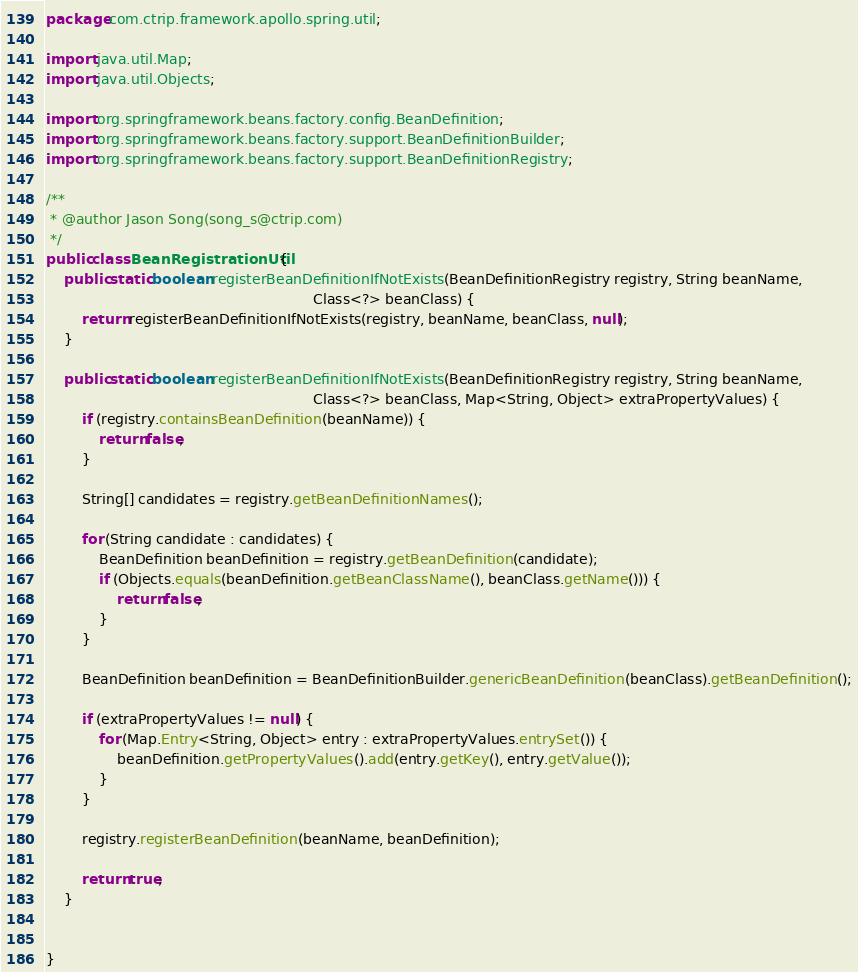<code> <loc_0><loc_0><loc_500><loc_500><_Java_>package com.ctrip.framework.apollo.spring.util;

import java.util.Map;
import java.util.Objects;

import org.springframework.beans.factory.config.BeanDefinition;
import org.springframework.beans.factory.support.BeanDefinitionBuilder;
import org.springframework.beans.factory.support.BeanDefinitionRegistry;

/**
 * @author Jason Song(song_s@ctrip.com)
 */
public class BeanRegistrationUtil {
    public static boolean registerBeanDefinitionIfNotExists(BeanDefinitionRegistry registry, String beanName,
                                                            Class<?> beanClass) {
        return registerBeanDefinitionIfNotExists(registry, beanName, beanClass, null);
    }

    public static boolean registerBeanDefinitionIfNotExists(BeanDefinitionRegistry registry, String beanName,
                                                            Class<?> beanClass, Map<String, Object> extraPropertyValues) {
        if (registry.containsBeanDefinition(beanName)) {
            return false;
        }

        String[] candidates = registry.getBeanDefinitionNames();

        for (String candidate : candidates) {
            BeanDefinition beanDefinition = registry.getBeanDefinition(candidate);
            if (Objects.equals(beanDefinition.getBeanClassName(), beanClass.getName())) {
                return false;
            }
        }

        BeanDefinition beanDefinition = BeanDefinitionBuilder.genericBeanDefinition(beanClass).getBeanDefinition();

        if (extraPropertyValues != null) {
            for (Map.Entry<String, Object> entry : extraPropertyValues.entrySet()) {
                beanDefinition.getPropertyValues().add(entry.getKey(), entry.getValue());
            }
        }

        registry.registerBeanDefinition(beanName, beanDefinition);

        return true;
    }


}
</code> 